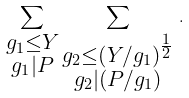Convert formula to latex. <formula><loc_0><loc_0><loc_500><loc_500>\sum _ { \substack { g _ { 1 } \leq Y \\ g _ { 1 } | P } } \sum _ { \substack { g _ { 2 } \leq \left ( Y / g _ { 1 } \right ) ^ { \frac { 1 } { 2 } } \\ g _ { 2 } | ( P / g _ { 1 } ) } } \, .</formula> 